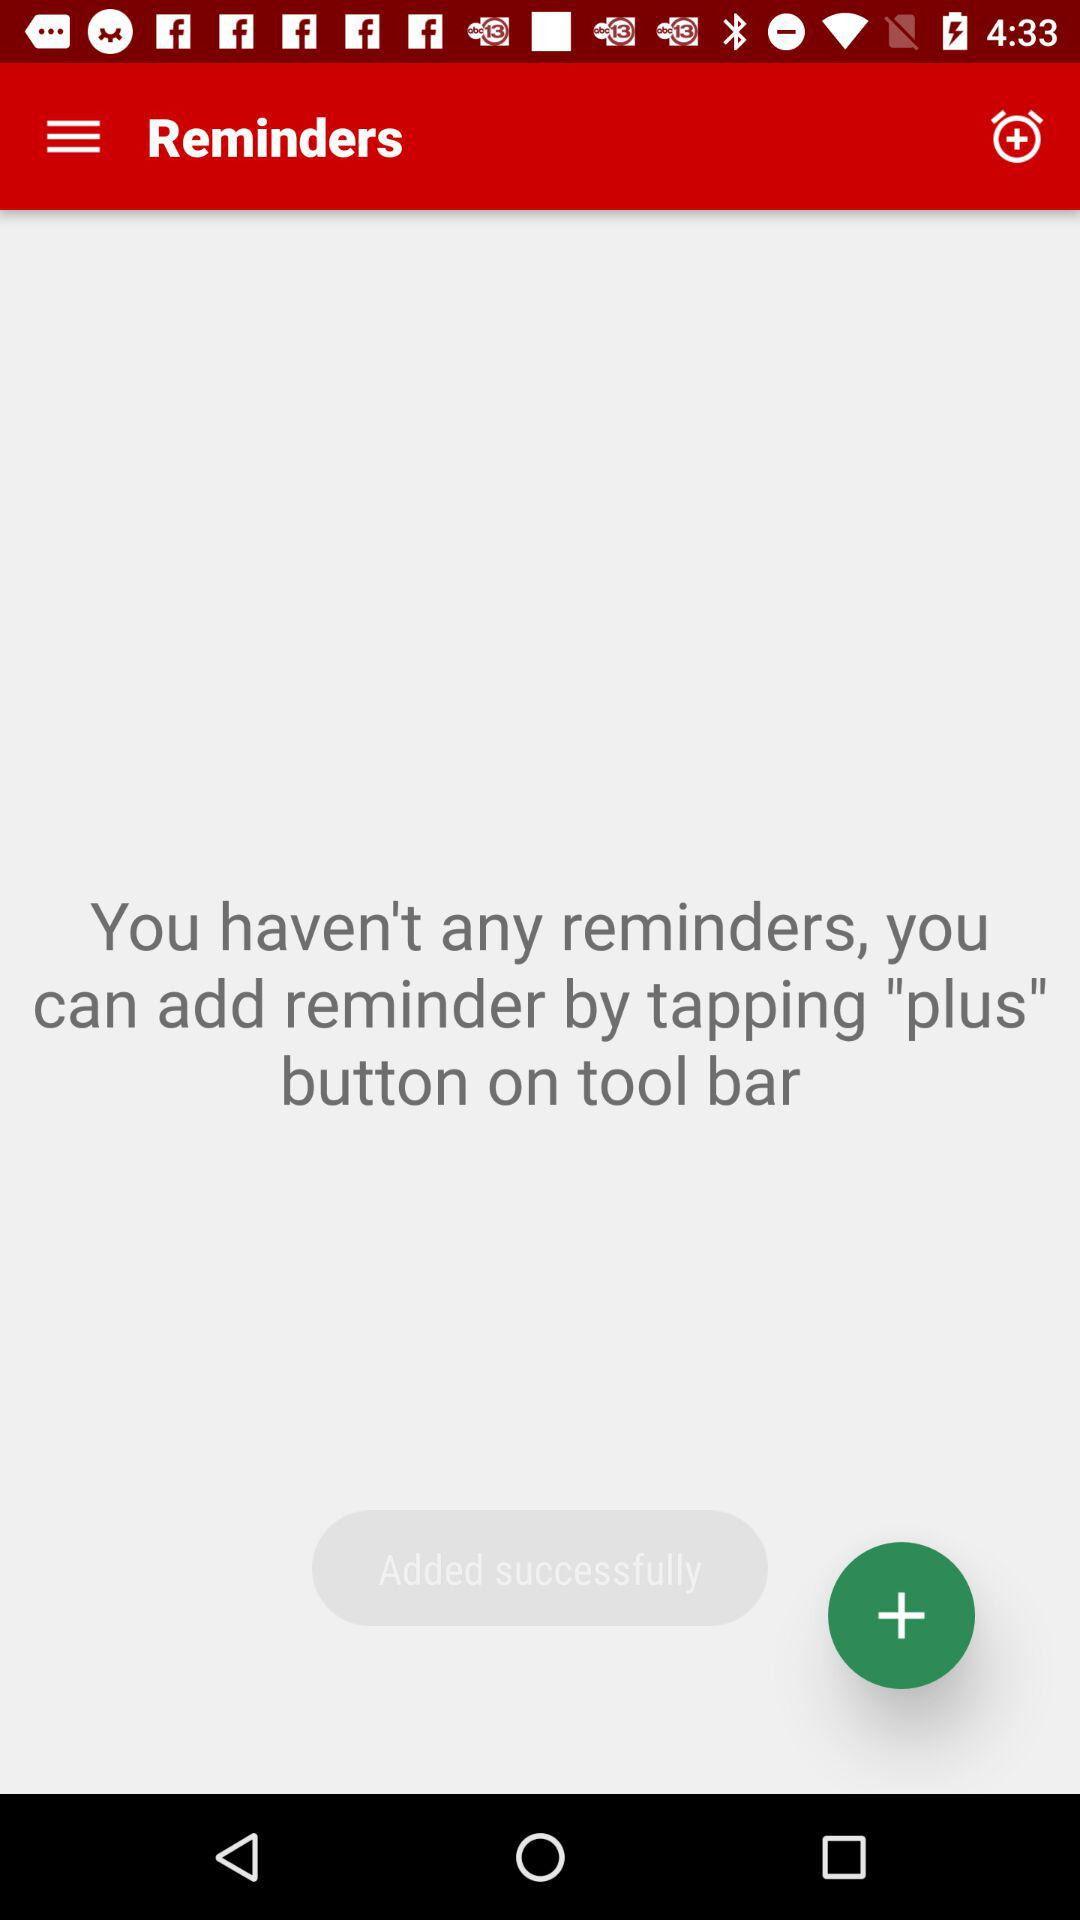When is the reminder for the doctor's appointment?
When the provided information is insufficient, respond with <no answer>. <no answer> 